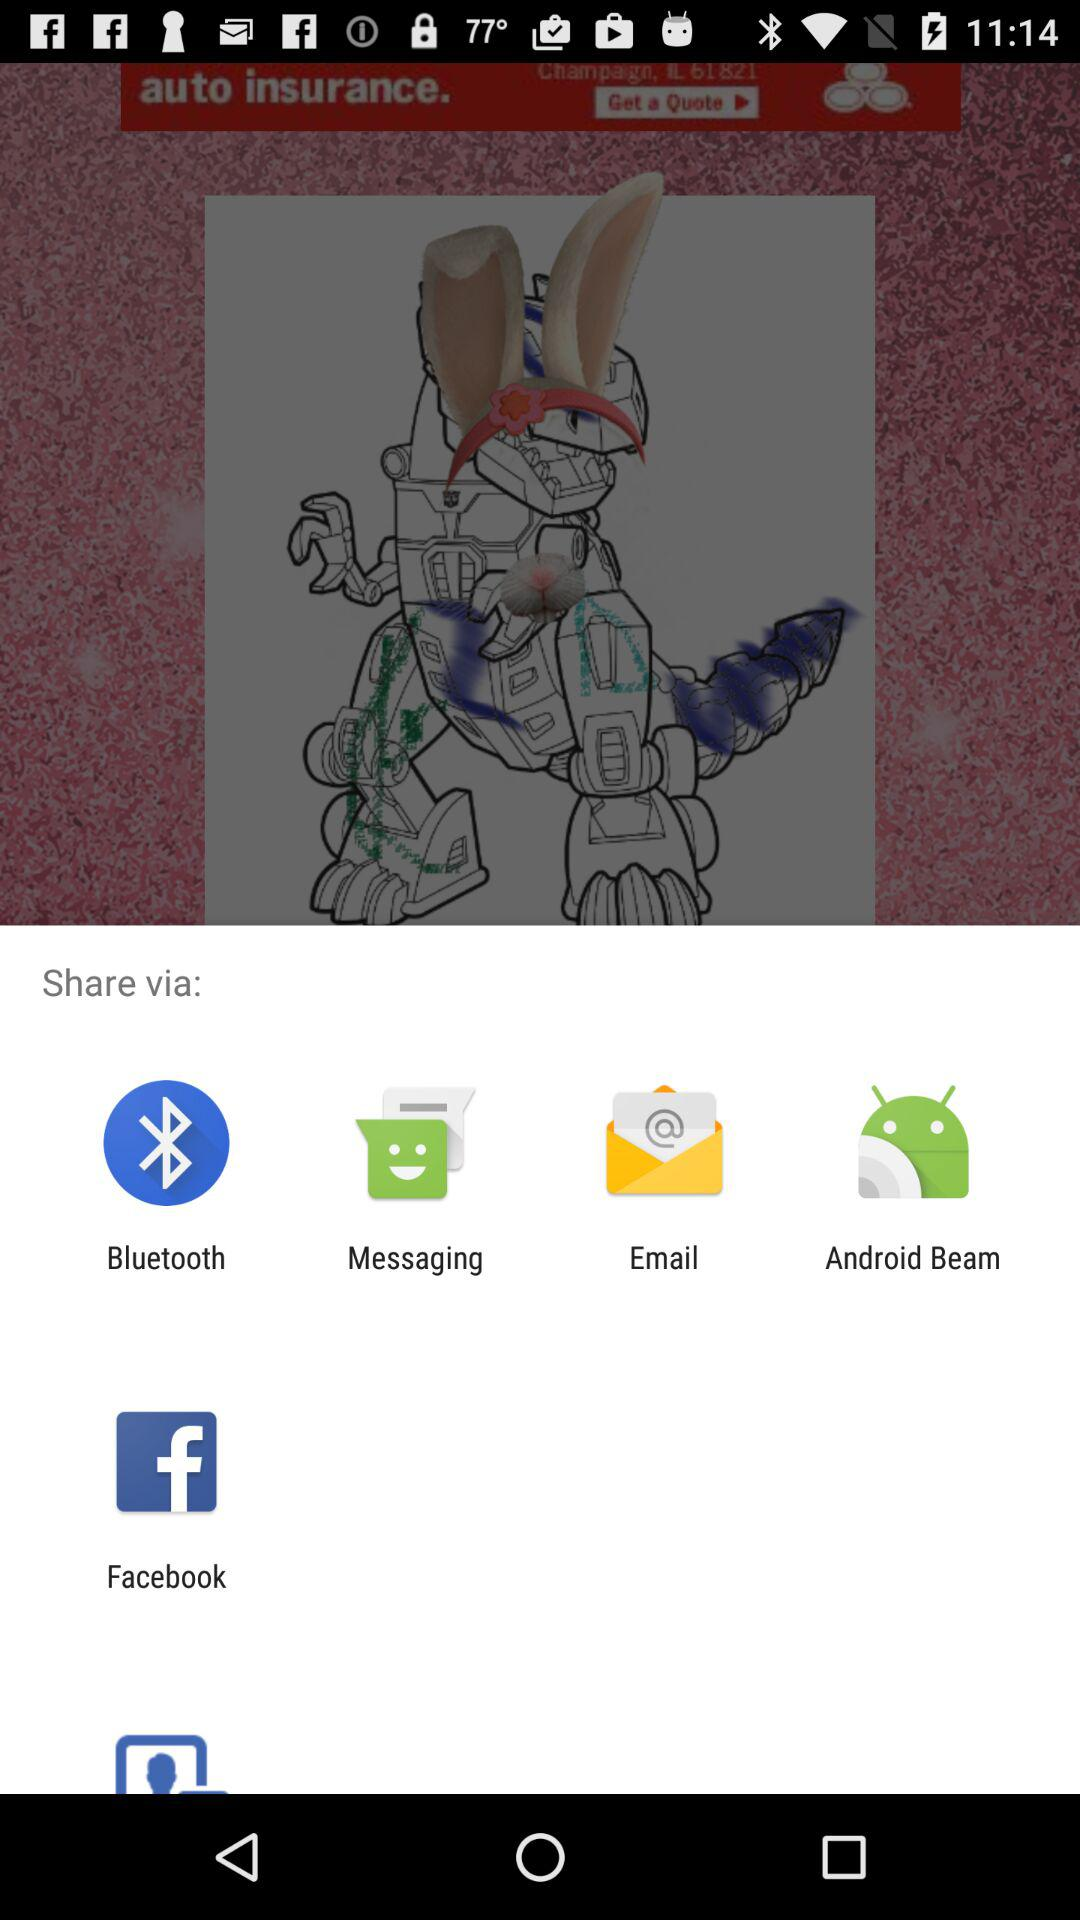What options are given for sharing? The options given for sharing are : "Bluetooth", "Messaging", "Email", "Android Beam" and " Facebook". 